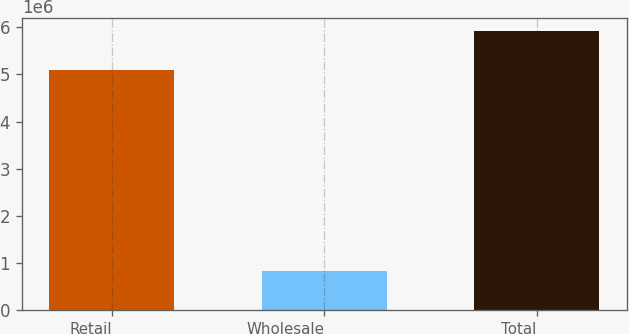<chart> <loc_0><loc_0><loc_500><loc_500><bar_chart><fcel>Retail<fcel>Wholesale<fcel>Total<nl><fcel>5.08749e+06<fcel>824640<fcel>5.91213e+06<nl></chart> 